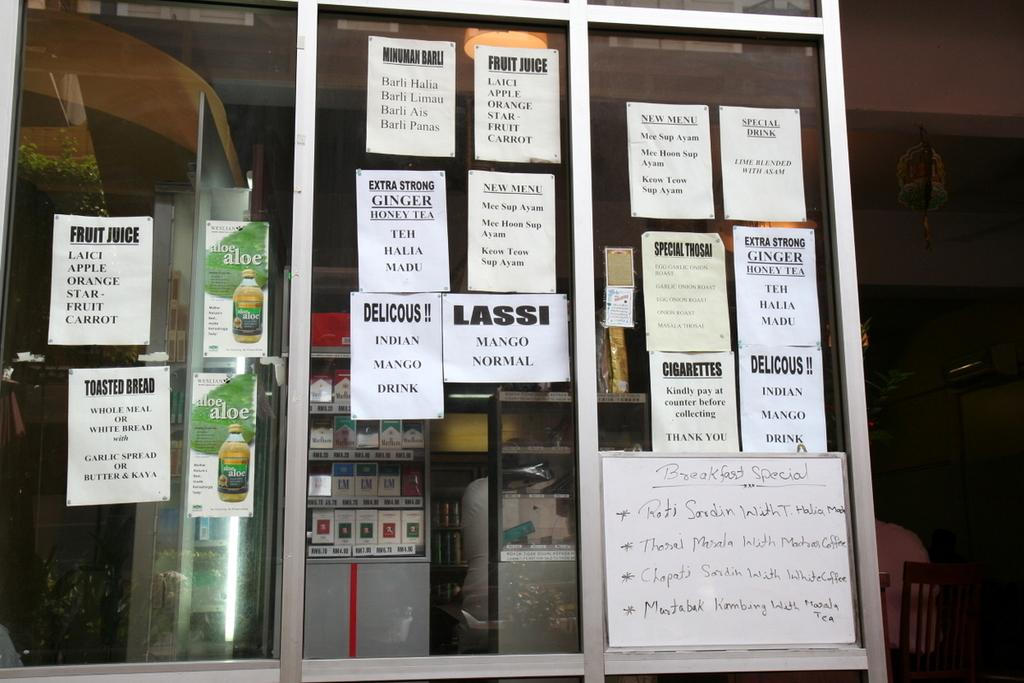Provide a one-sentence caption for the provided image. A store window has many signs advertising such things as fruit juice and cigarettes. 